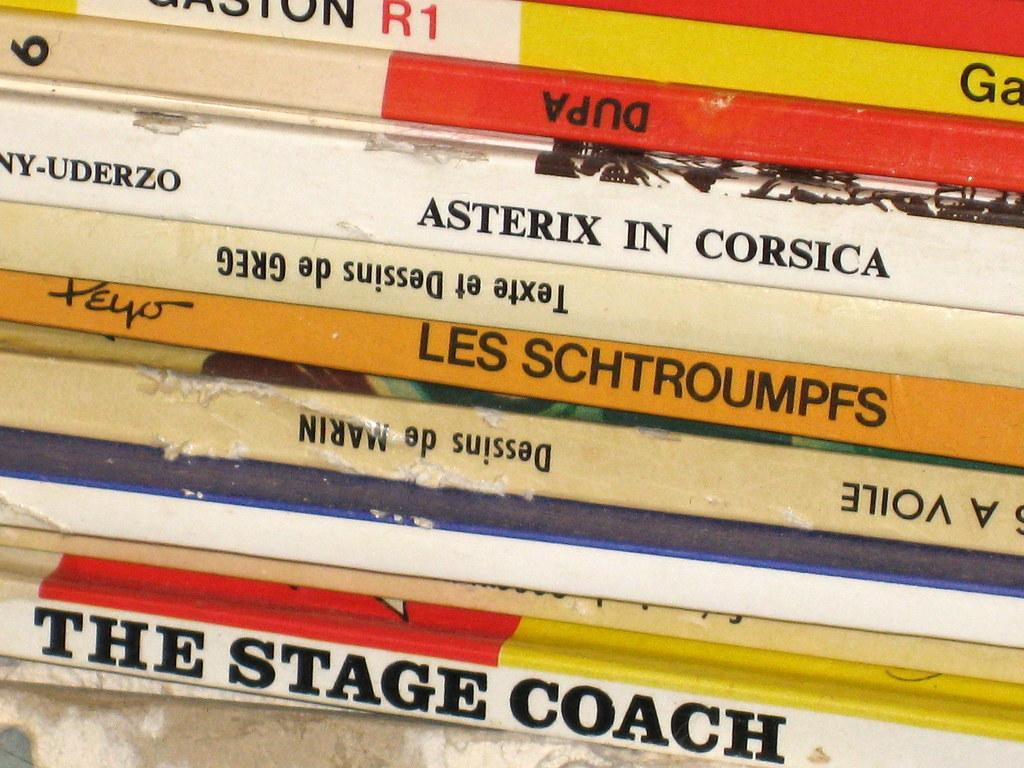<image>
Describe the image concisely. A closeup photo of a pile of old books starting with the stage coach. 